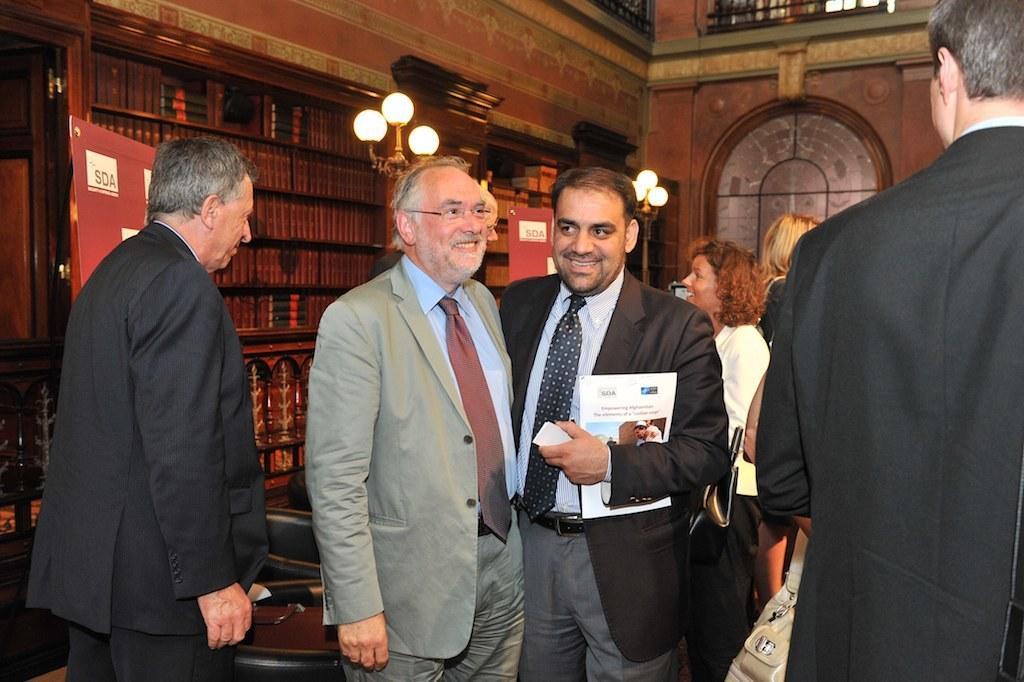Describe this image in one or two sentences. In this image we can see some group of men and women, men are wearing suits and in the background of the image there are some books arranged in the shelves, there are some lights, there is a wall and door. 